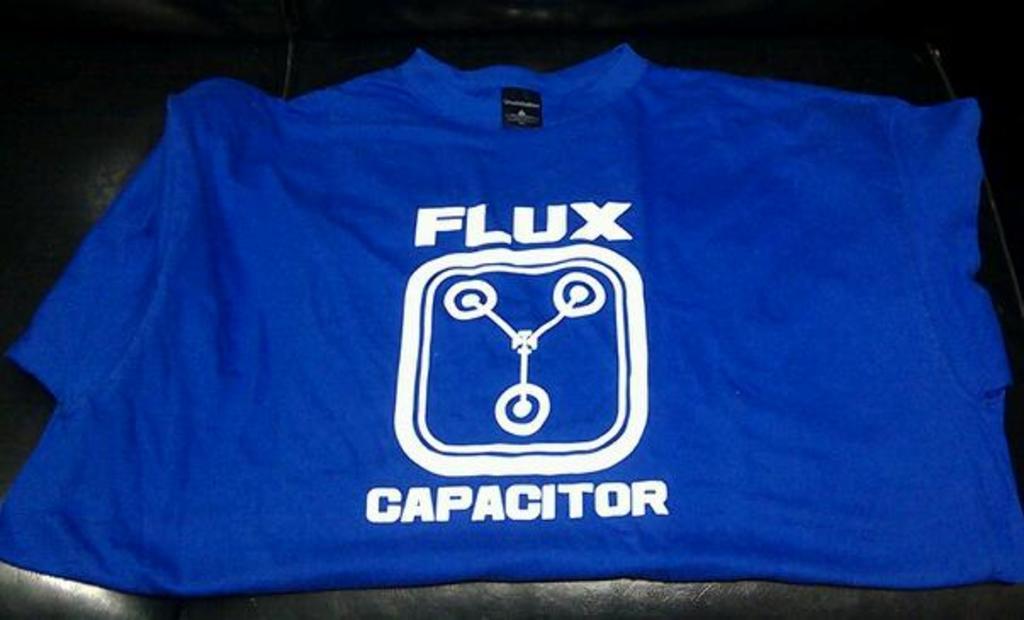What does the shirt's logo say?
Keep it short and to the point. Flux capacitor. 